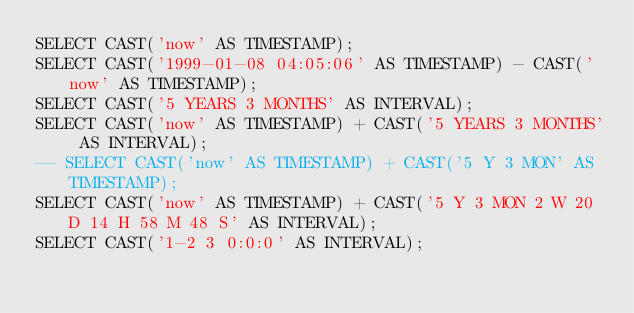<code> <loc_0><loc_0><loc_500><loc_500><_SQL_>SELECT CAST('now' AS TIMESTAMP);
SELECT CAST('1999-01-08 04:05:06' AS TIMESTAMP) - CAST('now' AS TIMESTAMP);
SELECT CAST('5 YEARS 3 MONTHS' AS INTERVAL);
SELECT CAST('now' AS TIMESTAMP) + CAST('5 YEARS 3 MONTHS' AS INTERVAL);
-- SELECT CAST('now' AS TIMESTAMP) + CAST('5 Y 3 MON' AS TIMESTAMP);
SELECT CAST('now' AS TIMESTAMP) + CAST('5 Y 3 MON 2 W 20 D 14 H 58 M 48 S' AS INTERVAL);
SELECT CAST('1-2 3 0:0:0' AS INTERVAL);
</code> 